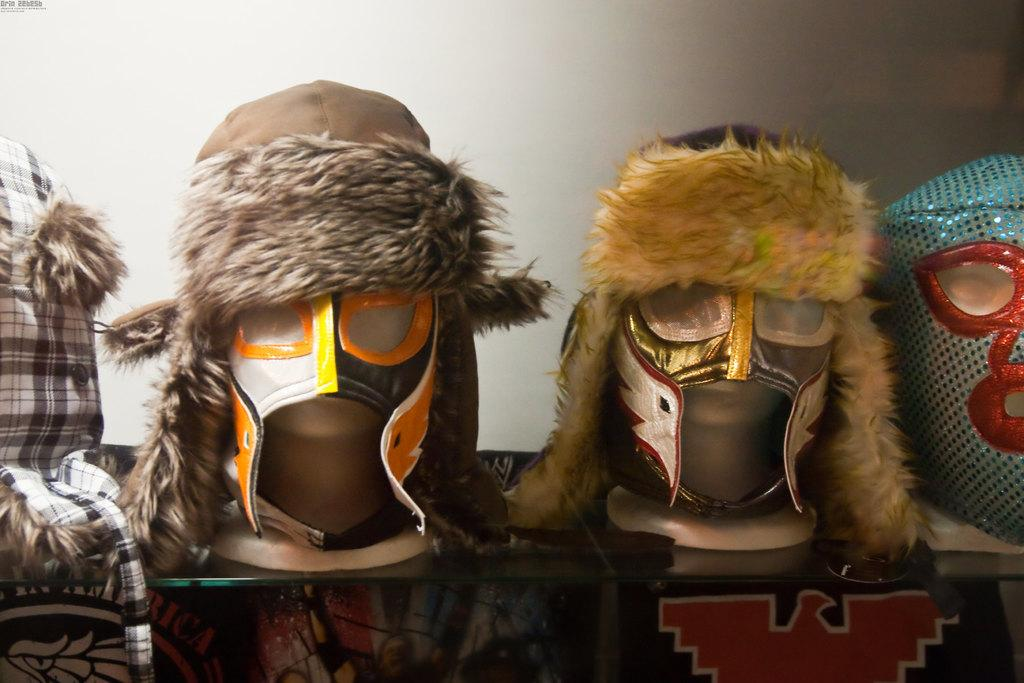What objects are arranged on a rack in the image? There are face masks arranged on a rack in the image. What can be seen in the background of the image? There is a plain wall in the background of the image. Is there any text visible in the image? Yes, there is some text in the top left corner of the image. What type of silk material is used to make the face masks in the image? There is no mention of silk or any specific material used to make the face masks in the image. 